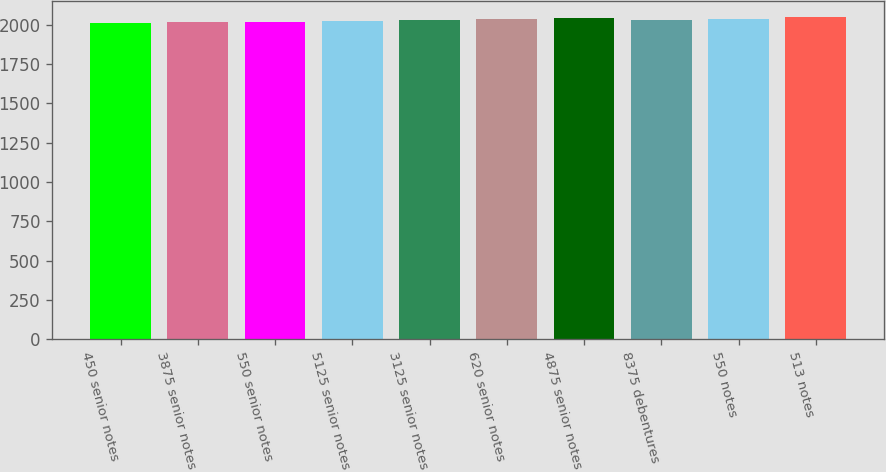Convert chart. <chart><loc_0><loc_0><loc_500><loc_500><bar_chart><fcel>450 senior notes<fcel>3875 senior notes<fcel>550 senior notes<fcel>5125 senior notes<fcel>3125 senior notes<fcel>620 senior notes<fcel>4875 senior notes<fcel>8375 debentures<fcel>550 notes<fcel>513 notes<nl><fcel>2013<fcel>2016.7<fcel>2020.4<fcel>2024.1<fcel>2031.5<fcel>2038.9<fcel>2042.6<fcel>2027.8<fcel>2035.2<fcel>2050<nl></chart> 